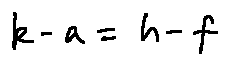Convert formula to latex. <formula><loc_0><loc_0><loc_500><loc_500>k - a = h - f</formula> 